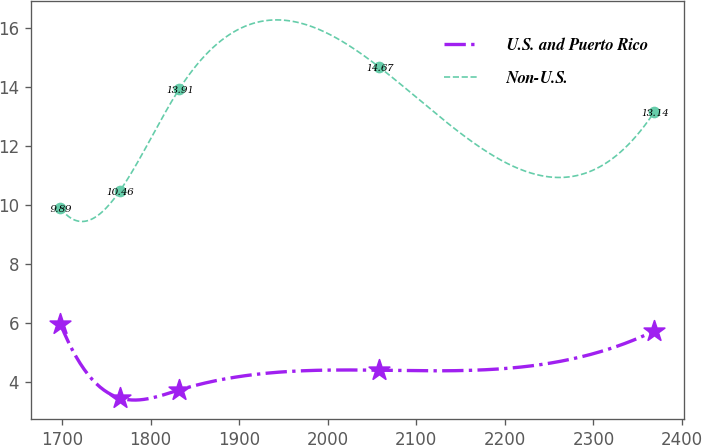Convert chart to OTSL. <chart><loc_0><loc_0><loc_500><loc_500><line_chart><ecel><fcel>U.S. and Puerto Rico<fcel>Non-U.S.<nl><fcel>1698<fcel>5.97<fcel>9.89<nl><fcel>1765.07<fcel>3.45<fcel>10.46<nl><fcel>1832.14<fcel>3.72<fcel>13.91<nl><fcel>2057.92<fcel>4.39<fcel>14.67<nl><fcel>2368.72<fcel>5.72<fcel>13.14<nl></chart> 